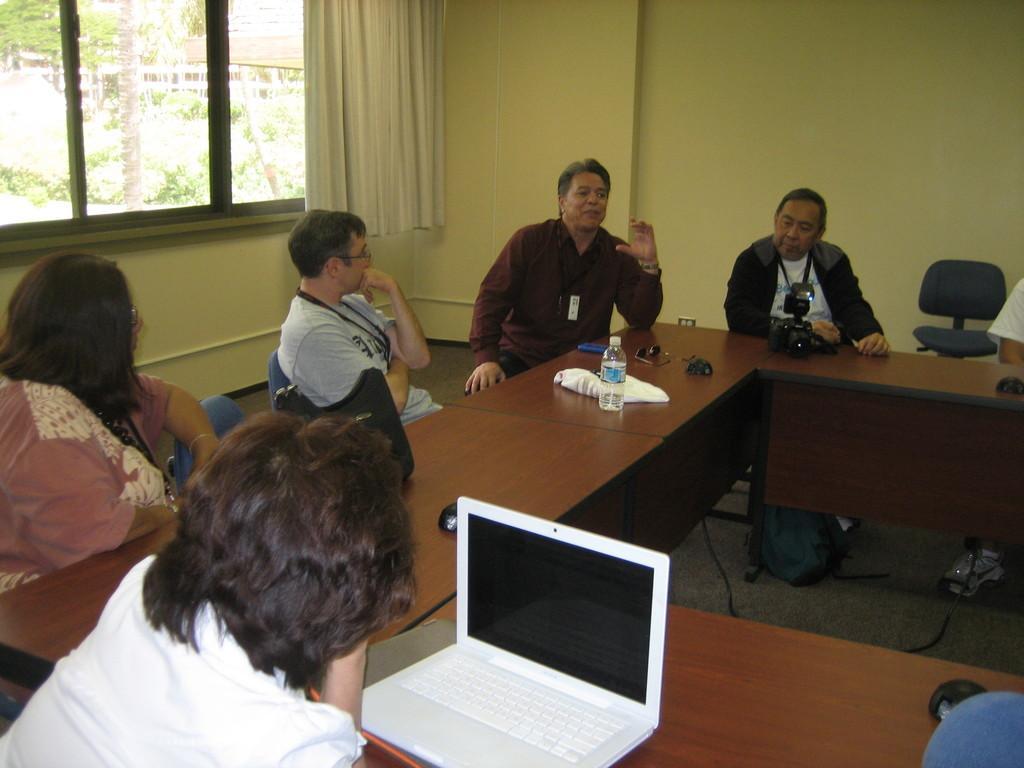How would you summarize this image in a sentence or two? As we can see in he image there is a window, curtain, yellow color wall, table and chairs. On chairs there are few people sitting. On table there is a bottle and a laptop. 